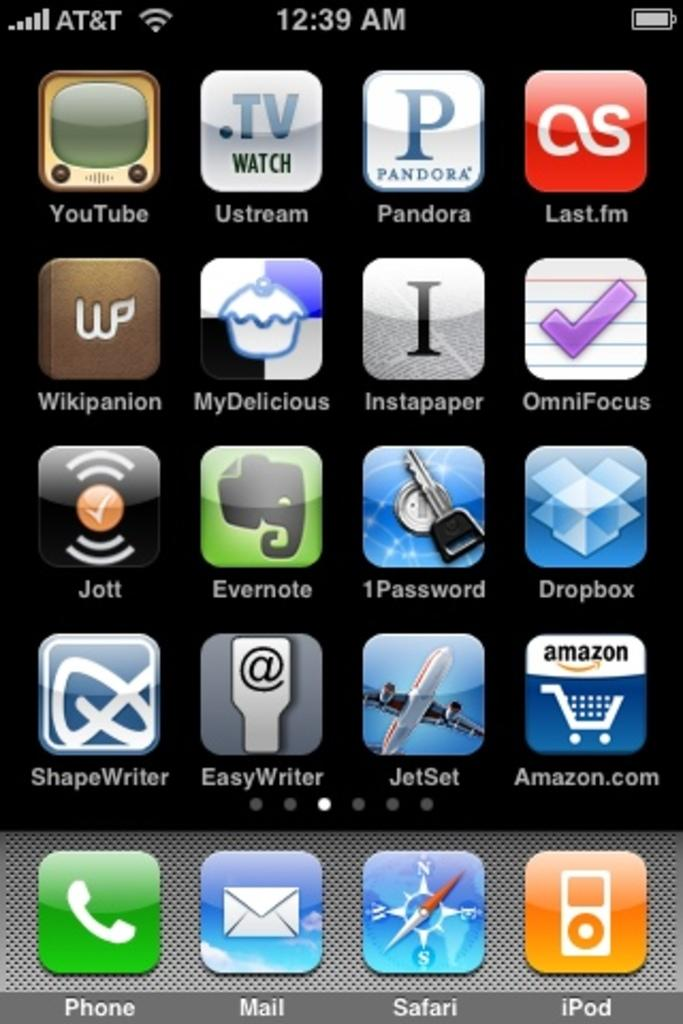What type of device is the image taken from? The image is a screenshot of a mobile. What can be seen on the mobile screen? There are applications and text visible in the image. Are there any numerical values present in the image? Yes, there are numbers visible in the image. Where is the basketball being played in the image? There is no basketball or any indication of a basketball game present in the image. 